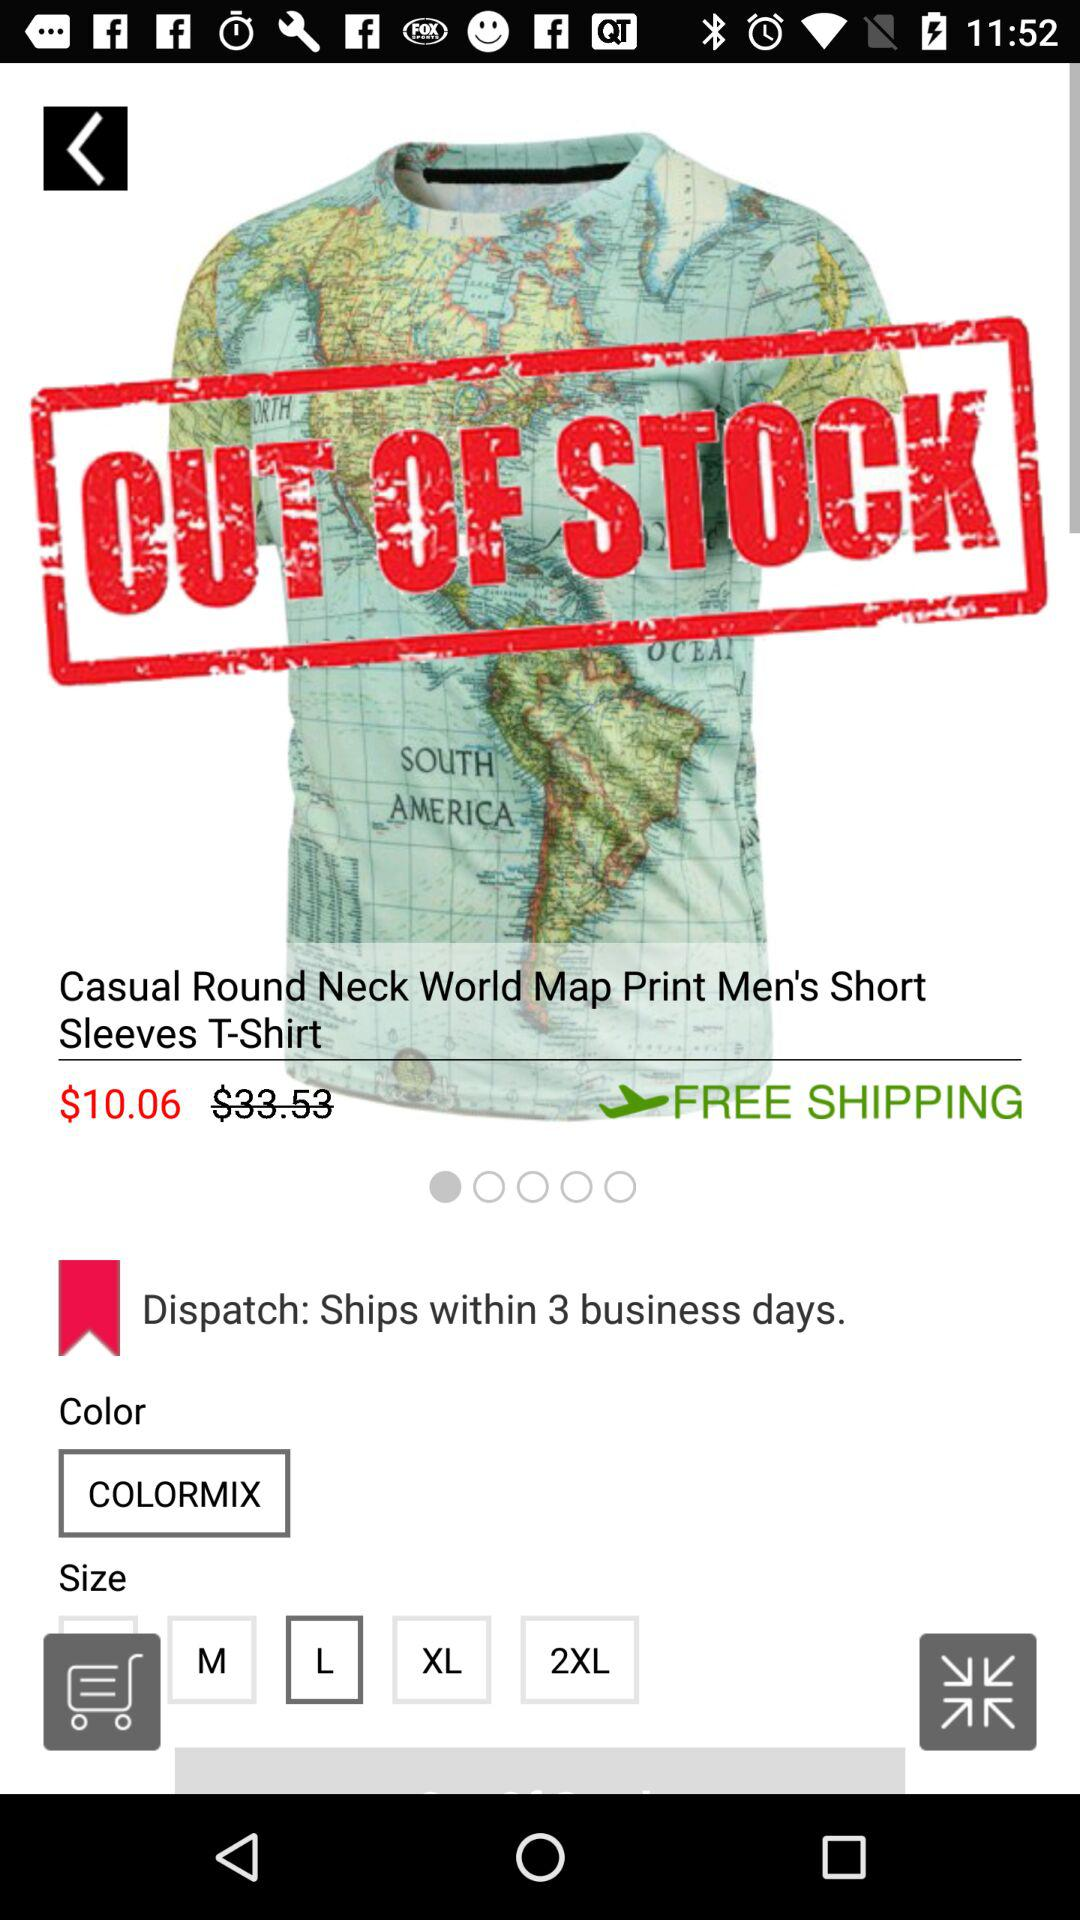What is the shiping time?
When the provided information is insufficient, respond with <no answer>. <no answer> 